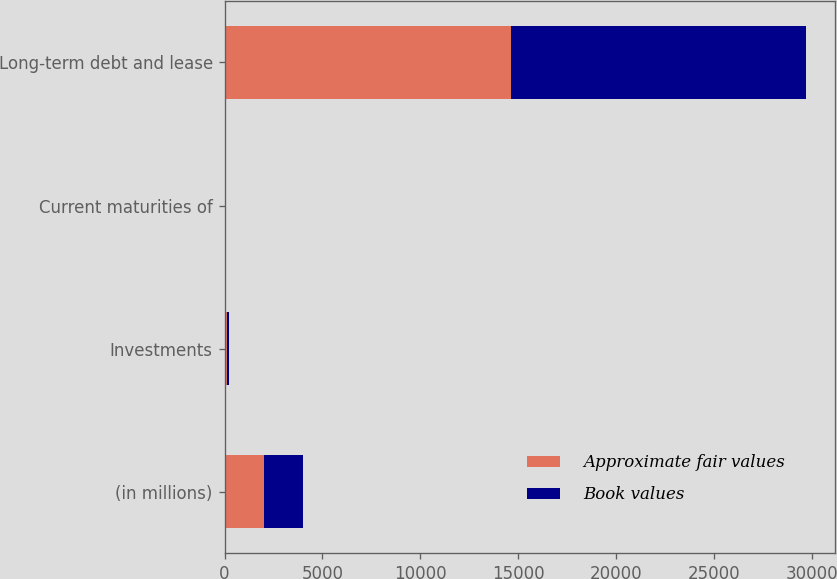Convert chart. <chart><loc_0><loc_0><loc_500><loc_500><stacked_bar_chart><ecel><fcel>(in millions)<fcel>Investments<fcel>Current maturities of<fcel>Long-term debt and lease<nl><fcel>Approximate fair values<fcel>2012<fcel>107<fcel>22<fcel>14630<nl><fcel>Book values<fcel>2012<fcel>104<fcel>22<fcel>15066<nl></chart> 